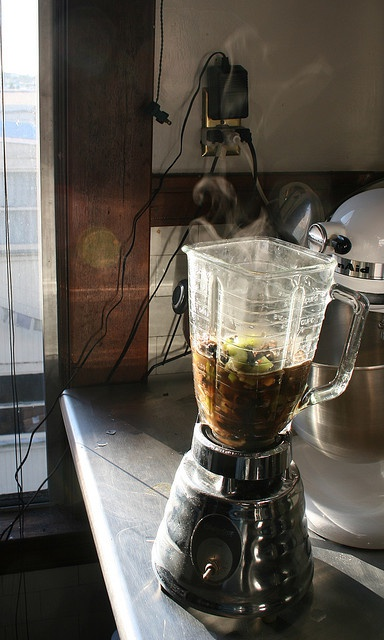Describe the objects in this image and their specific colors. I can see various objects in this image with different colors. 